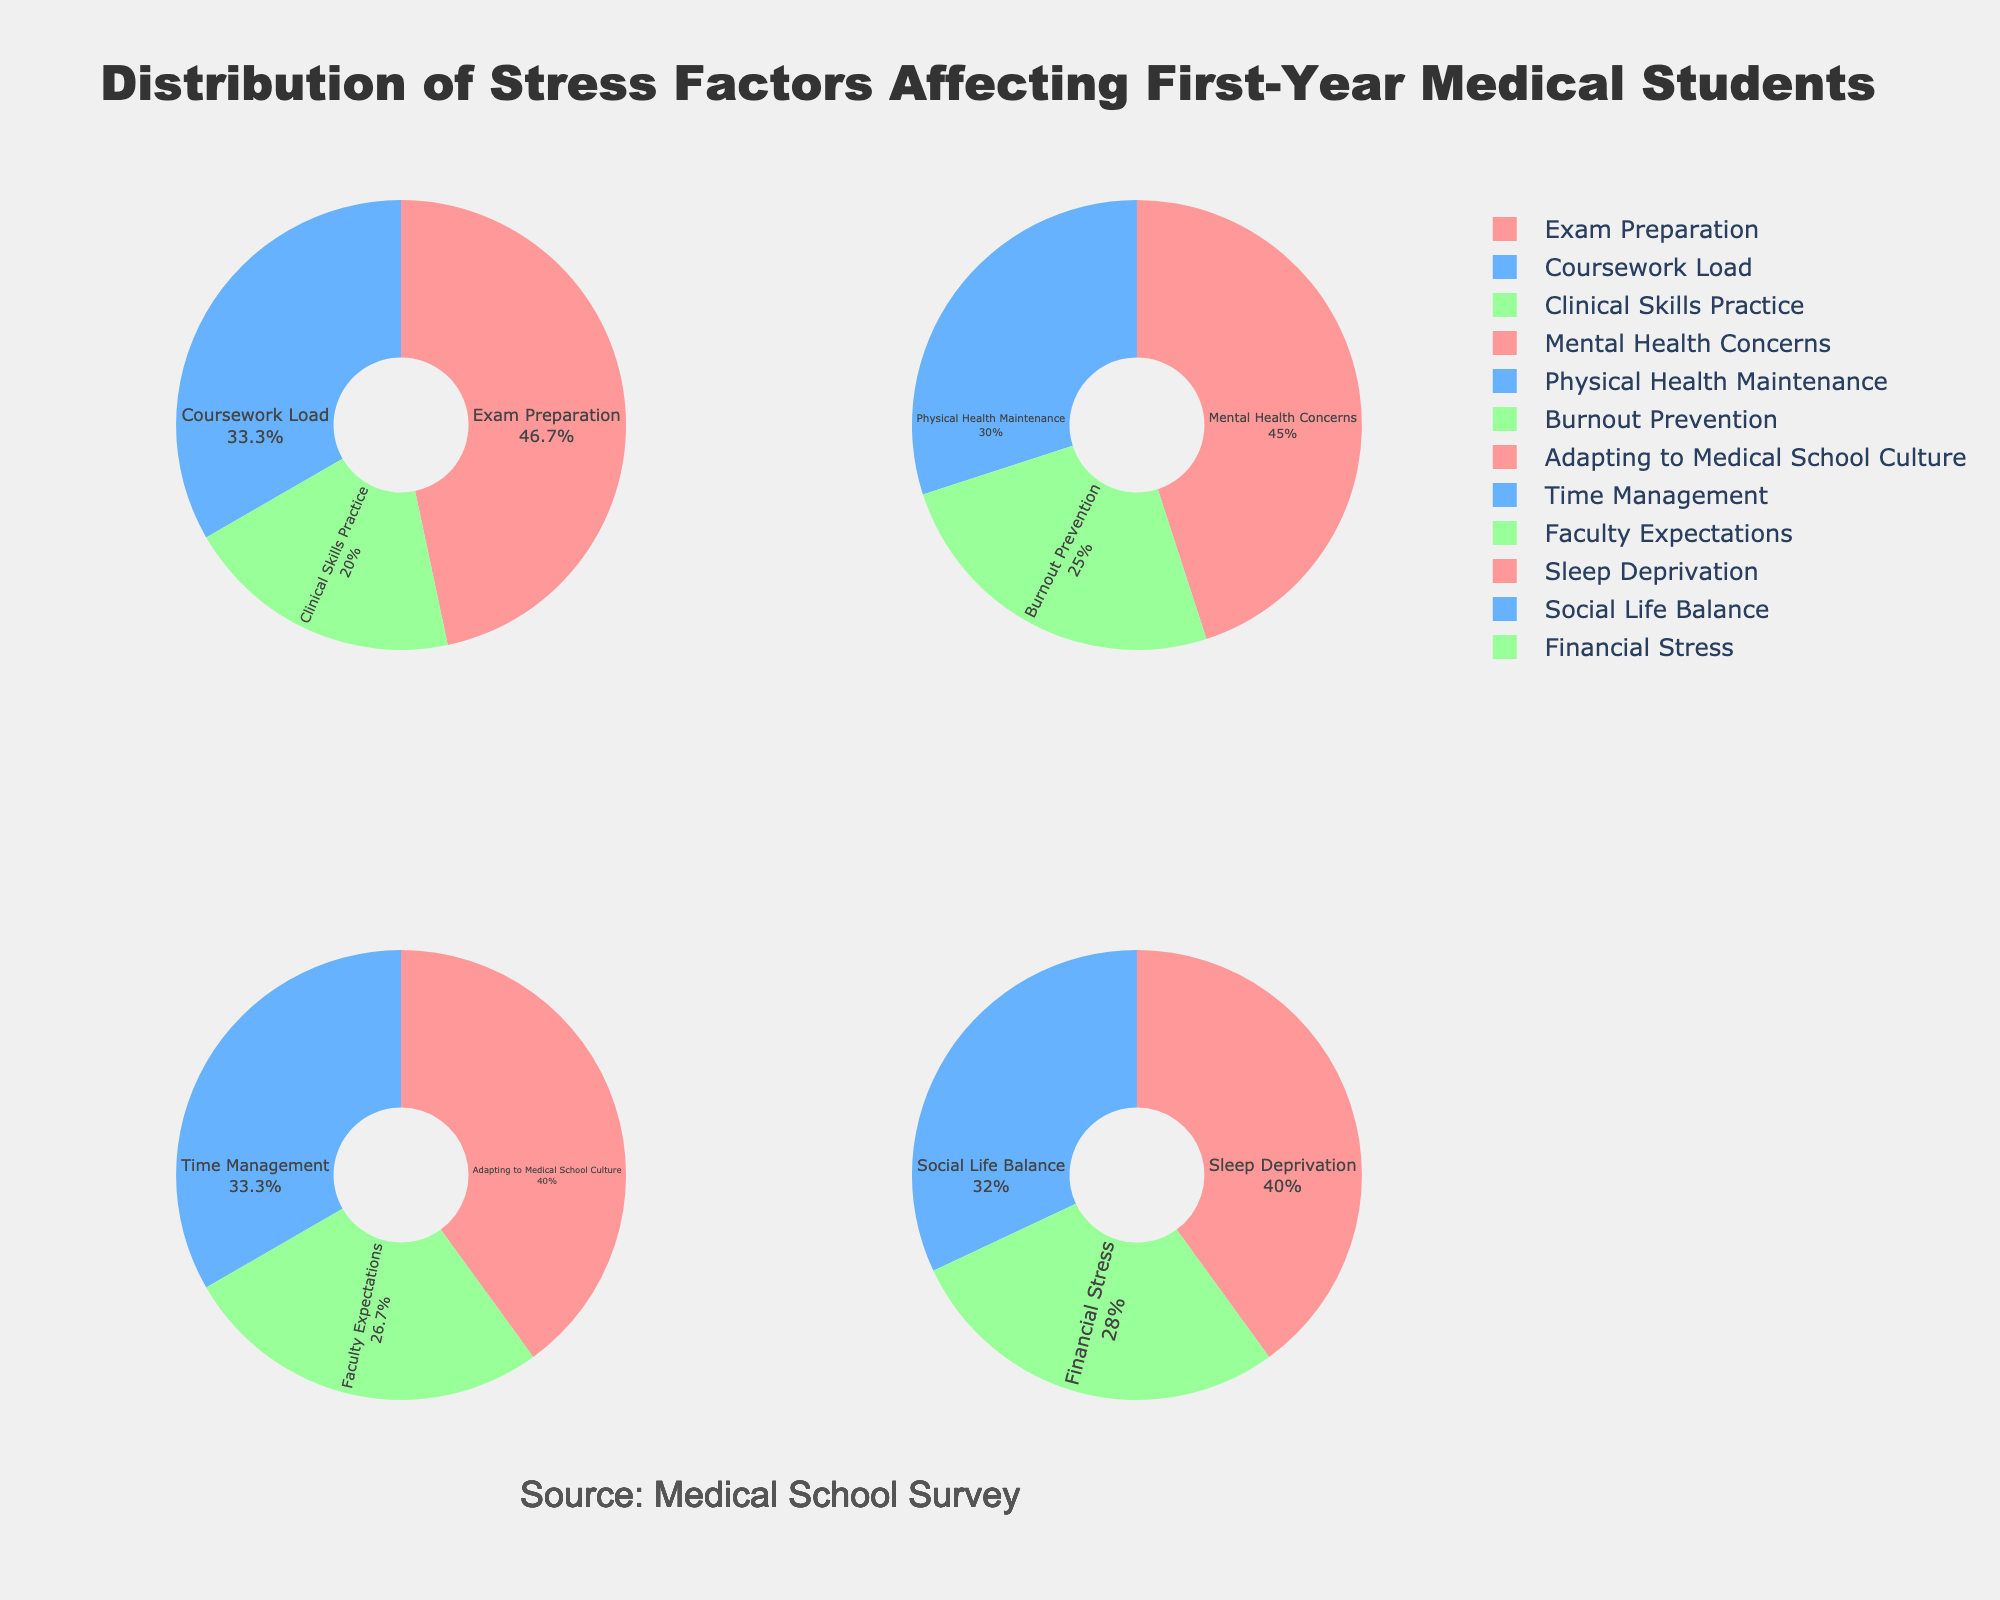What is the title of the figure? The title of the figure is positioned at the top center and reads "Energy Efficiency Impact on Property Value and Population Density".
Answer: Energy Efficiency Impact on Property Value and Population Density Which city has the highest average property value? In the first subplot (Energy Efficiency vs Property Value), the highest y-axis value corresponds to San Francisco. According to the hover text, San Francisco has an average property value of $1,500,000.
Answer: San Francisco How does population density affect the size of bubbles in the first subplot? The size of the bubbles in the first subplot is directly proportional to the population density of the respective city; larger bubbles represent higher population density. This can be observed by looking at cities like New York and Miami, which have larger bubbles indicating higher population densities.
Answer: Directly proportional Which city has the lowest energy efficiency rating? By consulting the x-axis in either subplot (Energy Efficiency vs Property Value or Energy Efficiency vs Population Density), the lowest x-axis value belongs to Houston, which has an energy efficiency rating of 68.
Answer: Houston What is the population density of Chicago? In the second subplot (Energy Efficiency vs Population Density), locate the bubble representing Chicago either by hovering over the bubble or by finding the energy efficiency rating of 72. The hover text will show that Chicago's population density is 11,842.
Answer: 11,842 What is the color scale used in the figure to represent energy efficiency ratings? The color scale for the energy efficiency ratings transitions through shades of Salmon, PaleGreen, SkyBlue, Plum, and Khaki. These colors are used across both subplots to visually encode the energy efficiency ratings of cities.
Answer: Salmon, PaleGreen, SkyBlue, Plum, Khaki Which city has a higher average property value, Boston or Los Angeles? By referencing the first subplot (Energy Efficiency vs Property Value), the y-axis values or hover text for Boston and Los Angeles show that Boston has an average property value of $750,000, while Los Angeles has $950,000.
Answer: Los Angeles How many cities have an energy efficiency rating above 80? In both subplots, locate the bubbles where the x-values are greater than 80. These cities are New York, San Francisco, Washington DC, Seattle, Boston, and Portland, giving a total of 6 cities.
Answer: 6 Which city has the largest bubble in the second subplot? In the second subplot (Energy Efficiency vs Population Density), the largest bubble represents the highest average property value. San Francisco has the largest bubble, indicating the highest property value.
Answer: San Francisco 